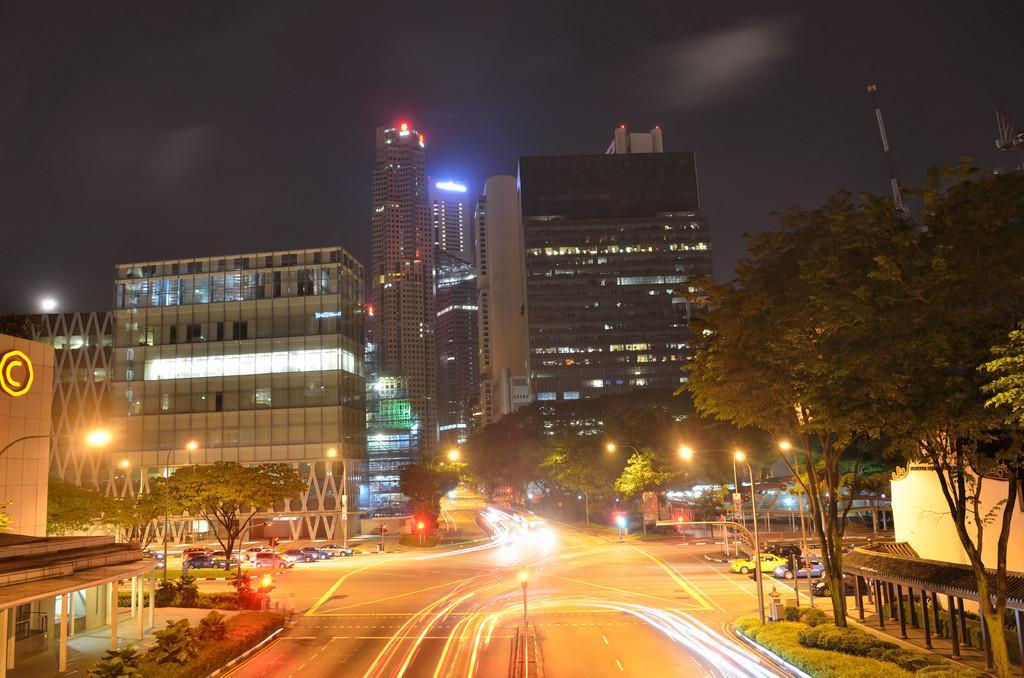How would you summarize this image in a sentence or two? In this image we can see buildings, trees, motor vehicles on the road, street poles, street lights, towers and sky. 